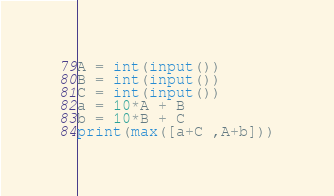<code> <loc_0><loc_0><loc_500><loc_500><_Python_>A = int(input())
B = int(input())
C = int(input())
a = 10*A + B
b = 10*B + C
print(max([a+C ,A+b]))</code> 